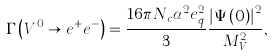Convert formula to latex. <formula><loc_0><loc_0><loc_500><loc_500>\Gamma \left ( V ^ { 0 } \rightarrow e ^ { + } e ^ { - } \right ) = \frac { 1 6 \pi N _ { c } \alpha ^ { 2 } e ^ { 2 } _ { q } } { 3 } \frac { \left | \Psi \left ( 0 \right ) \right | ^ { 2 } } { M ^ { 2 } _ { V } } ,</formula> 